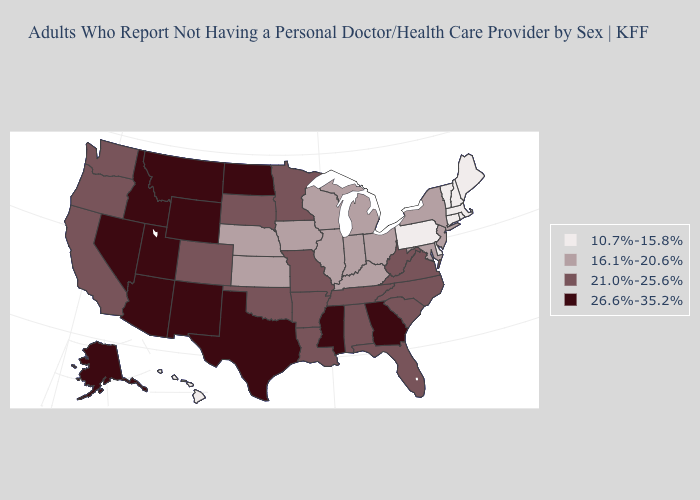Name the states that have a value in the range 10.7%-15.8%?
Answer briefly. Connecticut, Delaware, Hawaii, Maine, Massachusetts, New Hampshire, Pennsylvania, Rhode Island, Vermont. Name the states that have a value in the range 16.1%-20.6%?
Short answer required. Illinois, Indiana, Iowa, Kansas, Kentucky, Maryland, Michigan, Nebraska, New Jersey, New York, Ohio, Wisconsin. Name the states that have a value in the range 21.0%-25.6%?
Write a very short answer. Alabama, Arkansas, California, Colorado, Florida, Louisiana, Minnesota, Missouri, North Carolina, Oklahoma, Oregon, South Carolina, South Dakota, Tennessee, Virginia, Washington, West Virginia. Does Arkansas have the same value as South Carolina?
Concise answer only. Yes. Name the states that have a value in the range 16.1%-20.6%?
Write a very short answer. Illinois, Indiana, Iowa, Kansas, Kentucky, Maryland, Michigan, Nebraska, New Jersey, New York, Ohio, Wisconsin. Among the states that border Maryland , does Delaware have the highest value?
Quick response, please. No. Does Iowa have the lowest value in the USA?
Short answer required. No. Does the map have missing data?
Short answer required. No. What is the value of Connecticut?
Answer briefly. 10.7%-15.8%. What is the highest value in the Northeast ?
Short answer required. 16.1%-20.6%. What is the value of Iowa?
Keep it brief. 16.1%-20.6%. Does Illinois have the highest value in the USA?
Answer briefly. No. Does the map have missing data?
Give a very brief answer. No. Name the states that have a value in the range 16.1%-20.6%?
Be succinct. Illinois, Indiana, Iowa, Kansas, Kentucky, Maryland, Michigan, Nebraska, New Jersey, New York, Ohio, Wisconsin. Name the states that have a value in the range 21.0%-25.6%?
Give a very brief answer. Alabama, Arkansas, California, Colorado, Florida, Louisiana, Minnesota, Missouri, North Carolina, Oklahoma, Oregon, South Carolina, South Dakota, Tennessee, Virginia, Washington, West Virginia. 